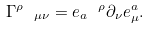Convert formula to latex. <formula><loc_0><loc_0><loc_500><loc_500>\Gamma ^ { \rho } \text { } _ { \mu \nu } = e _ { a } \text { } ^ { \rho } \partial _ { \nu } e _ { \mu } ^ { a } .</formula> 